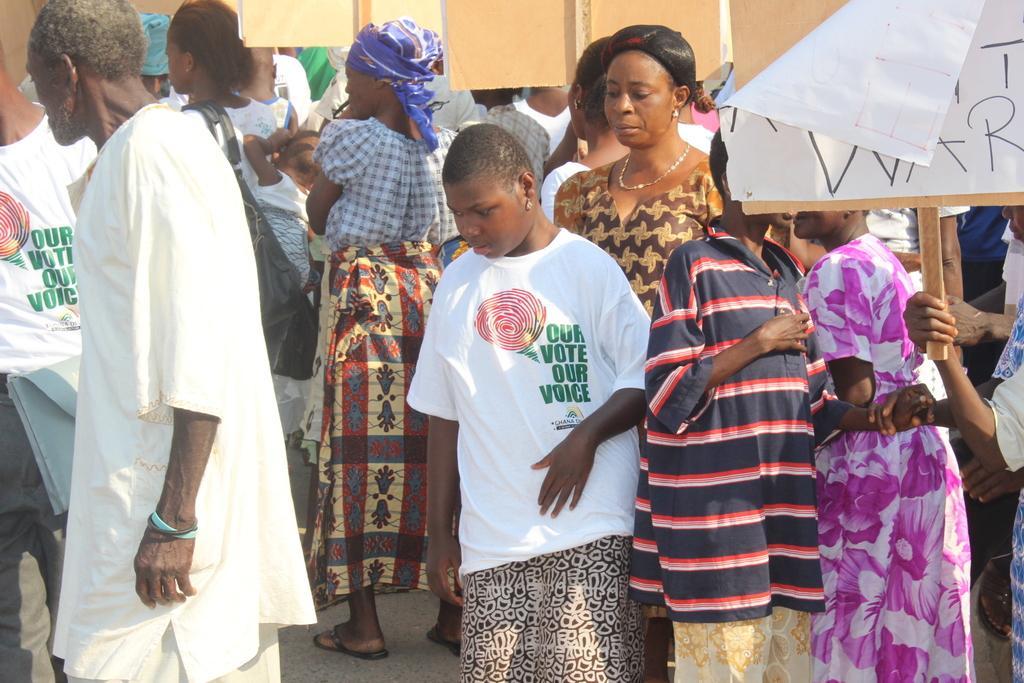Can you describe this image briefly? In this image I can see few people stand on road holding boards. Few people are wearing white T shirts which is with some text. 